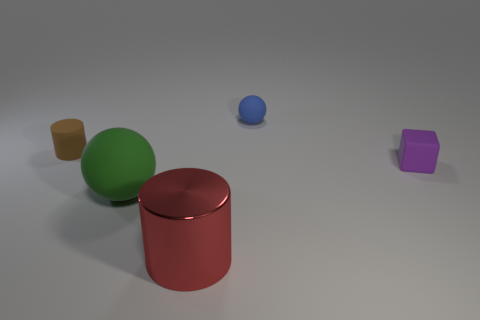Add 5 red shiny things. How many objects exist? 10 Subtract all spheres. How many objects are left? 3 Subtract 0 gray blocks. How many objects are left? 5 Subtract all yellow shiny balls. Subtract all blocks. How many objects are left? 4 Add 2 small purple cubes. How many small purple cubes are left? 3 Add 1 gray matte objects. How many gray matte objects exist? 1 